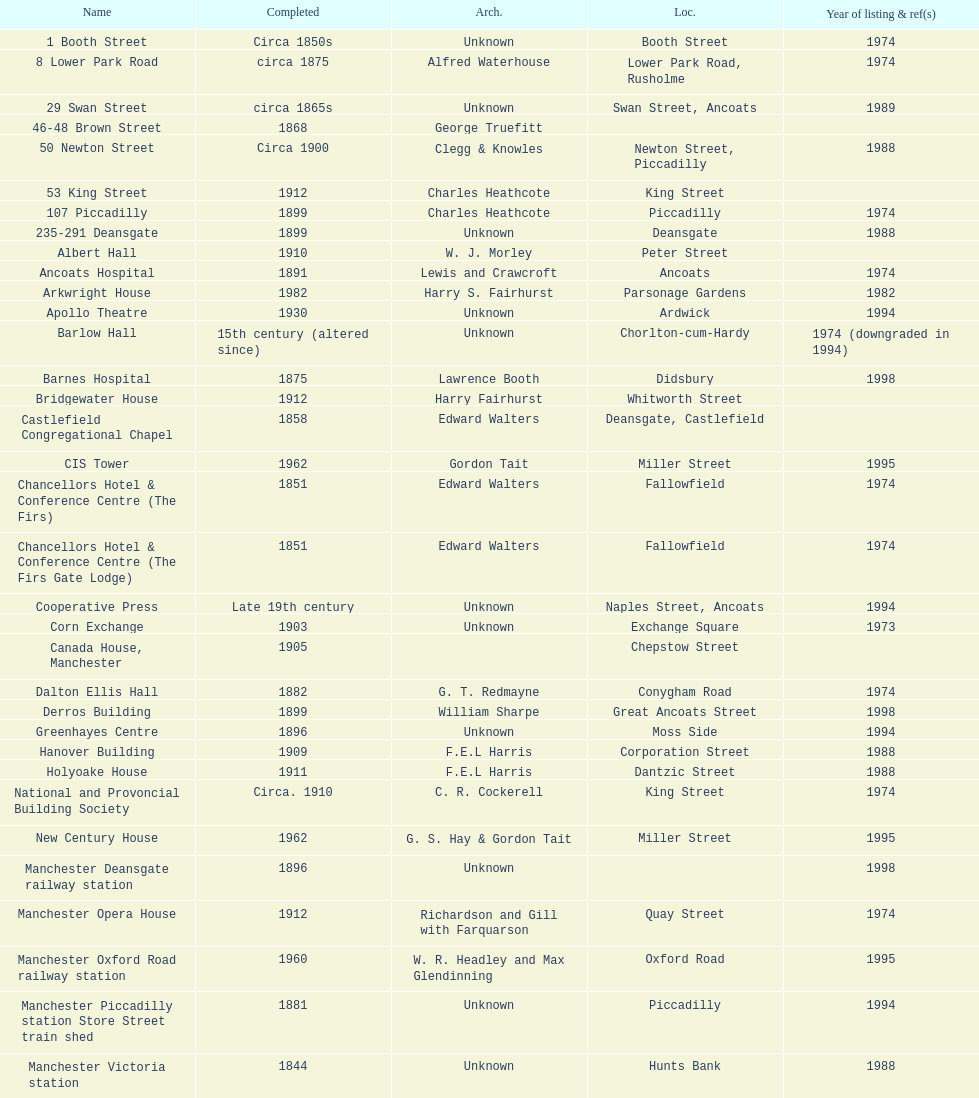Which two buildings were listed before 1974? The Old Wellington Inn, Smithfield Market Hall. 